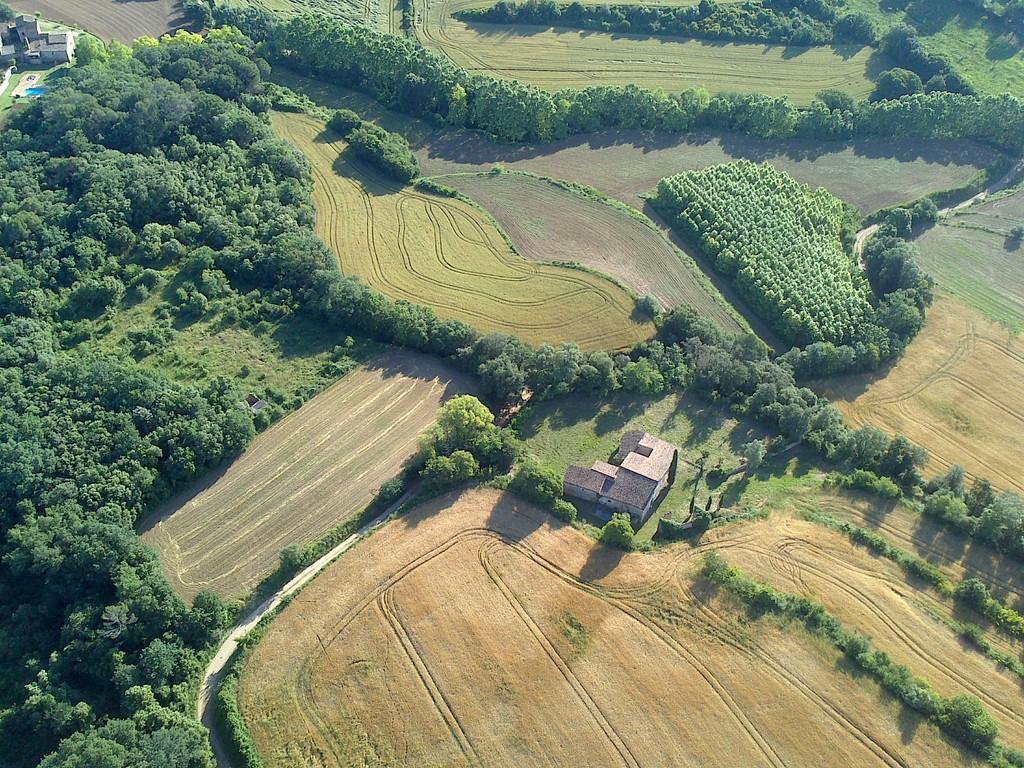Could you give a brief overview of what you see in this image? In this picture we can see the grass and few sheds on the ground, here we can see trees. 